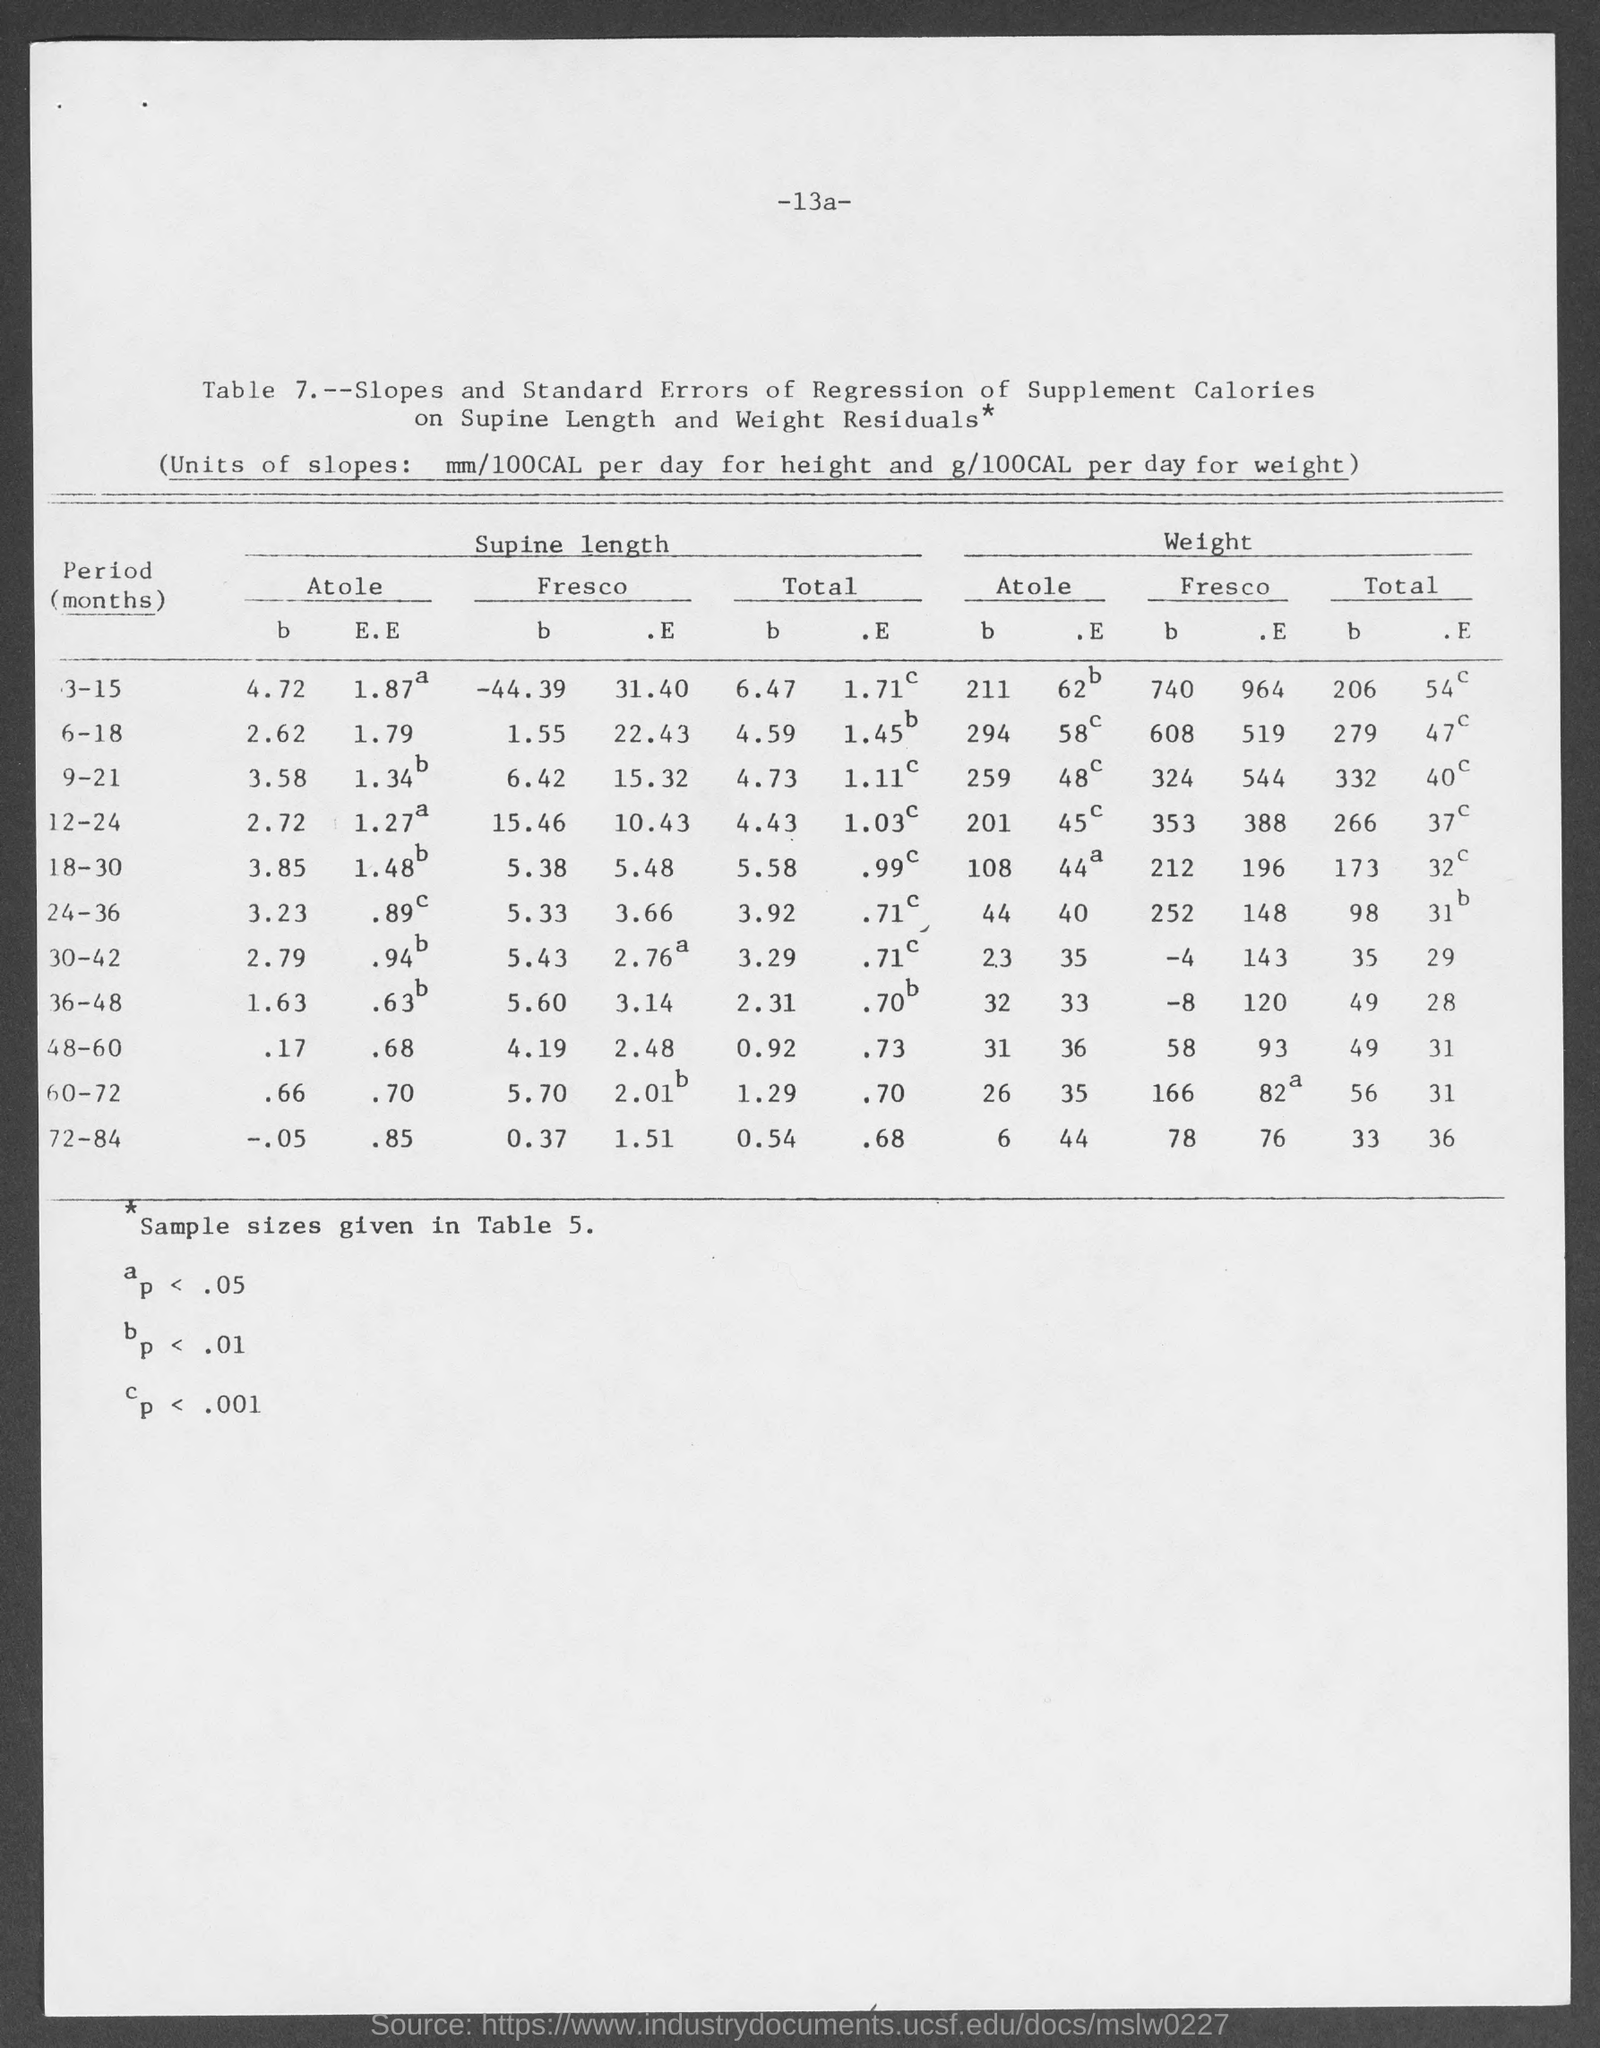Mention a couple of crucial points in this snapshot. The slopes of the growth curve for height and weight can be written as mm/100CAL per day and g/100CAL per day, respectively. 